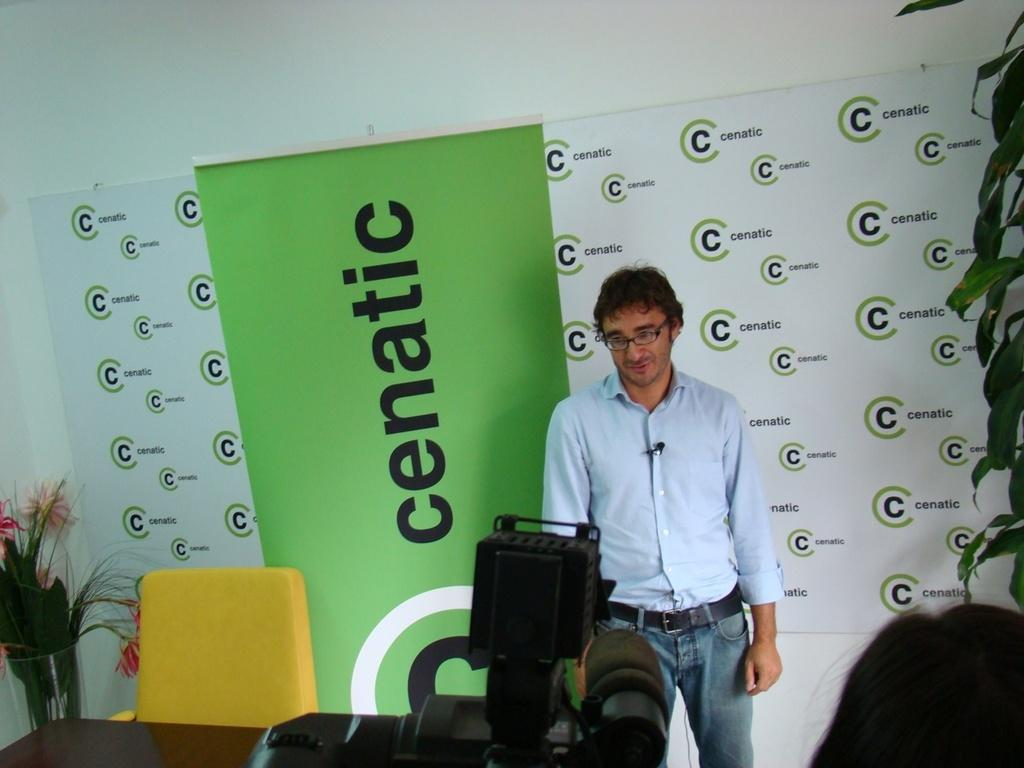How many people are in the image? There are two people in the image. Can you describe one of the people? One of the people is a man wearing spectacles. What is the man doing in the image? The man is standing. What objects can be seen in the image related to photography? There is a camera in the image. What type of furniture is present in the image? There is a table and a chair in the image. What natural elements are present in the image? Leaves and flowers are present in the image. What type of glass object is in the image? There is a glass object in the image. What is on the wall in the image? There is a banner on the wall in the image. What type of skin condition is visible on the man's face in the image? There is no mention of any skin condition on the man's face in the image. 